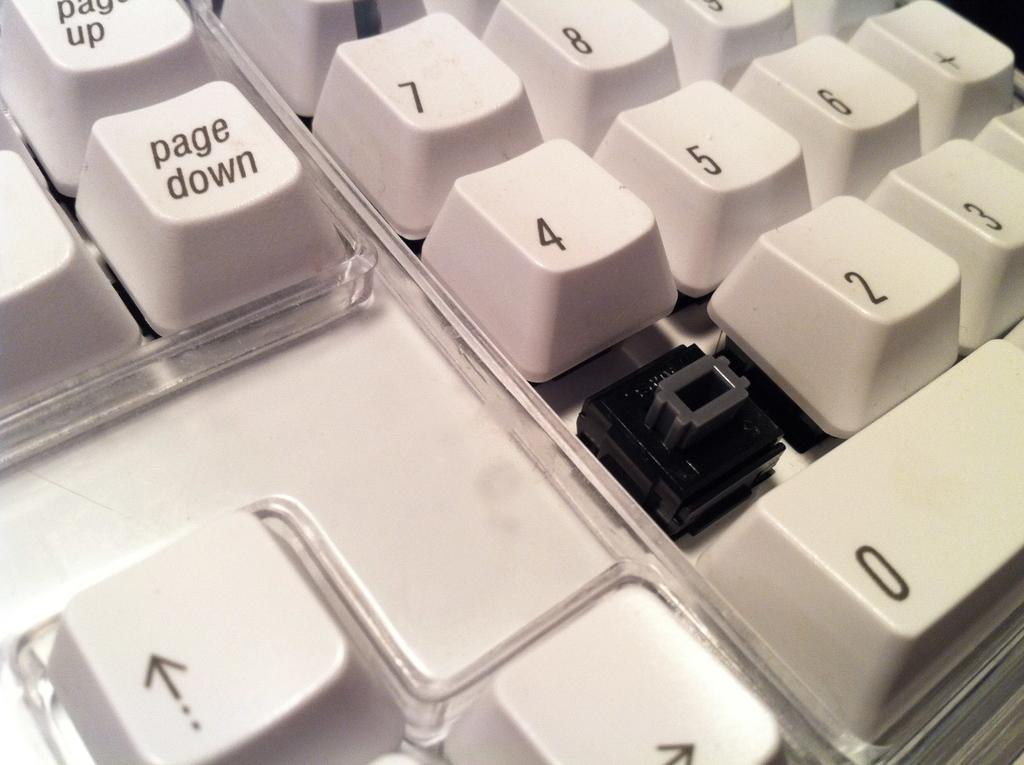<image>
Render a clear and concise summary of the photo. A closeup of a white keyboard with a key missing under the key labelled 4. 